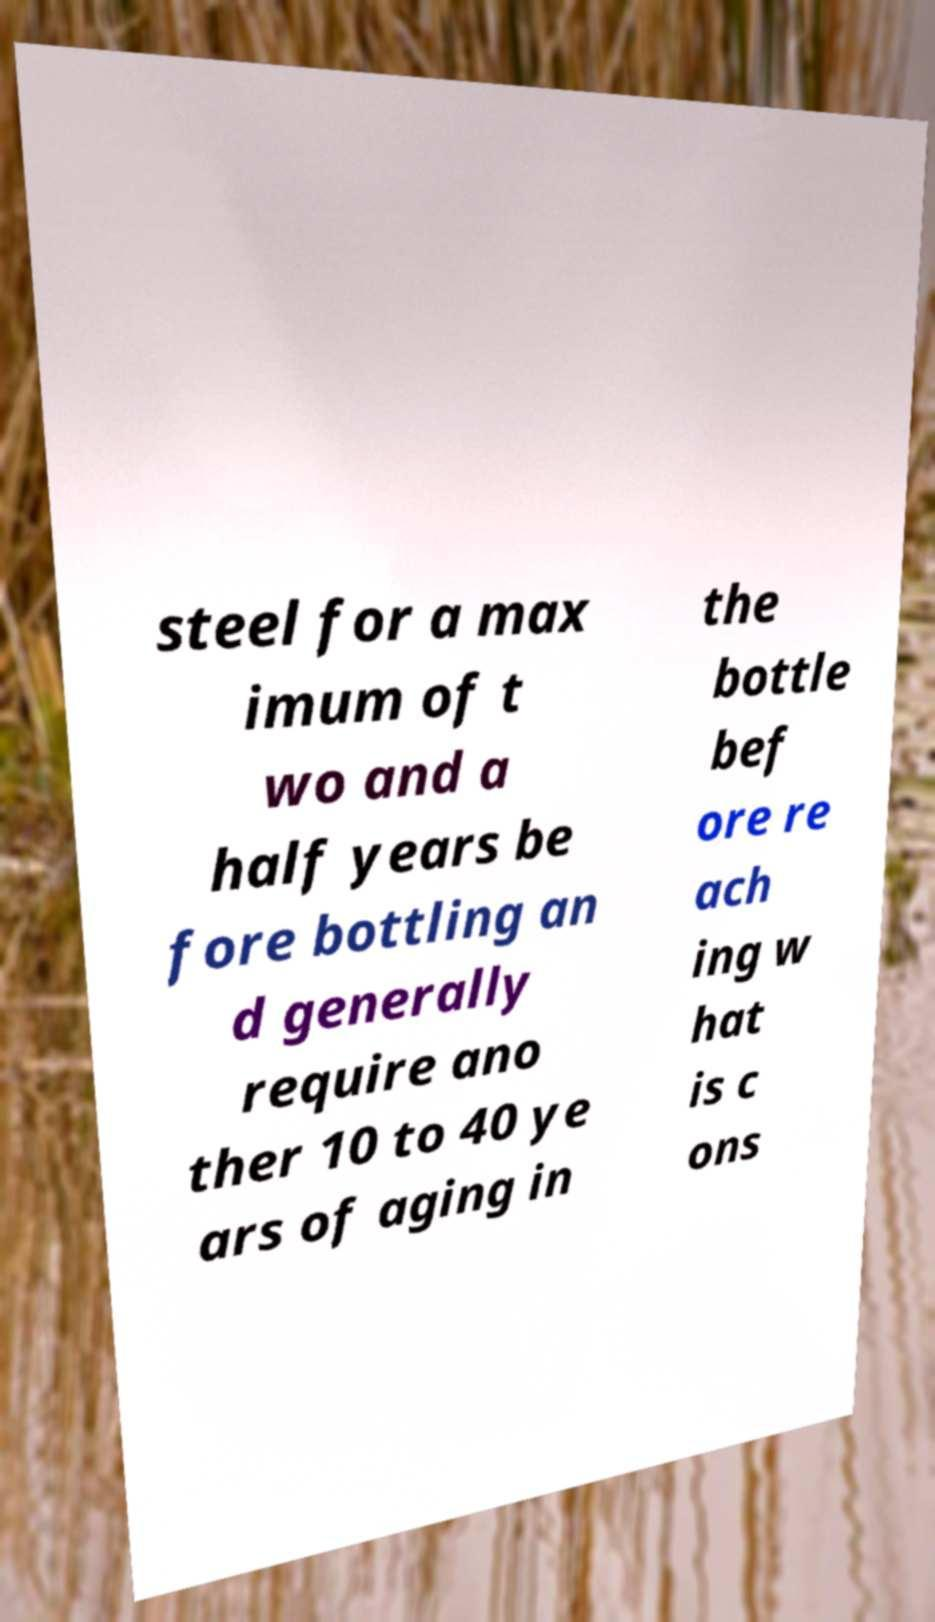Can you accurately transcribe the text from the provided image for me? steel for a max imum of t wo and a half years be fore bottling an d generally require ano ther 10 to 40 ye ars of aging in the bottle bef ore re ach ing w hat is c ons 